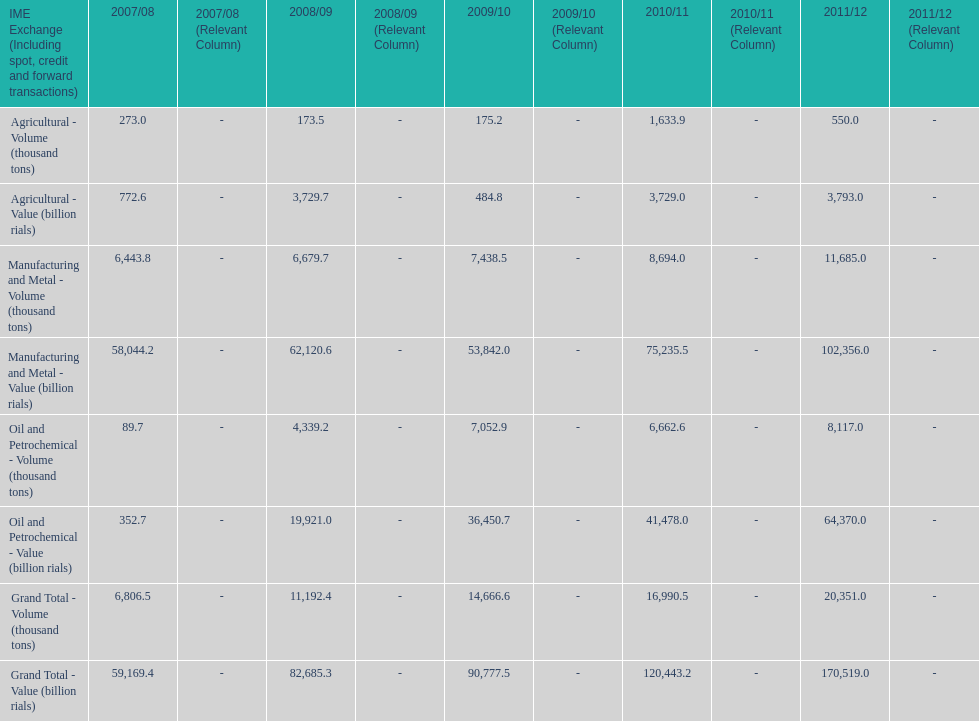What is the total agricultural value in 2008/09? 3,729.7. 